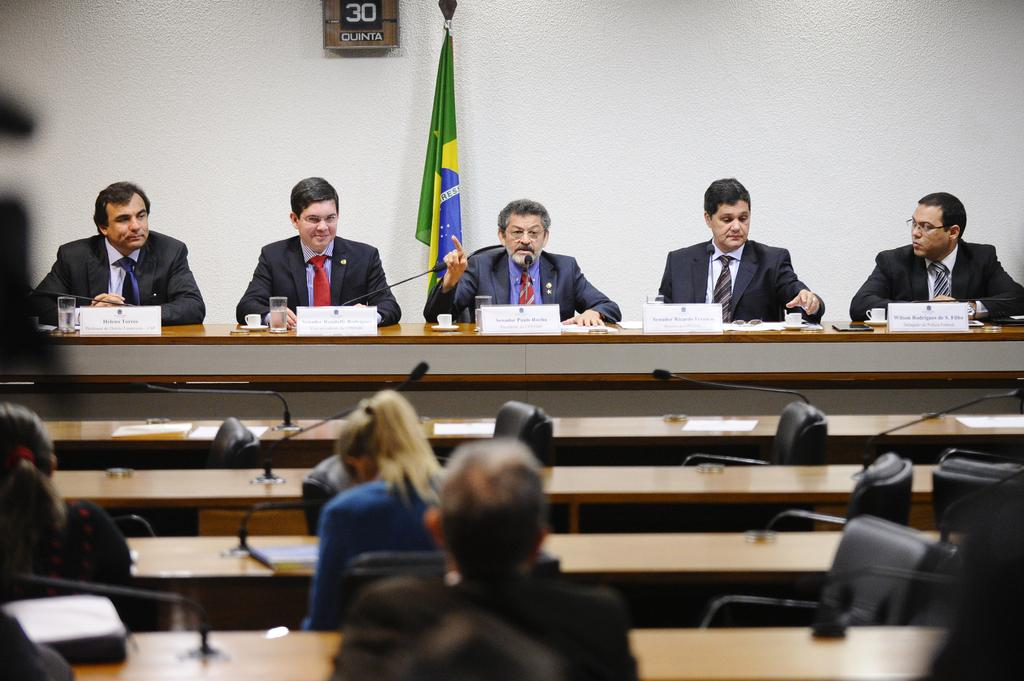What type of seating is visible in the image? There are chairs and benches in the image. What are the people on the chairs and benches doing? The people on chairs and benches are looking at each other. Can you describe the interaction between the people in the image? The people are engaging in eye contact, suggesting a form of communication or connection. What type of straw is being used by the people in the image? There is no straw present in the image; the people are simply looking at each other while sitting on chairs and benches. 